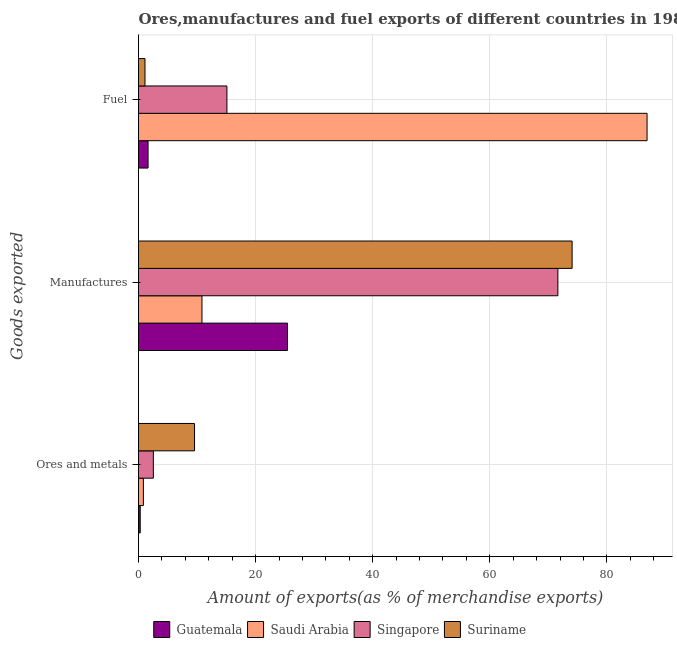How many groups of bars are there?
Your answer should be very brief. 3. What is the label of the 1st group of bars from the top?
Make the answer very short. Fuel. What is the percentage of ores and metals exports in Saudi Arabia?
Give a very brief answer. 0.83. Across all countries, what is the maximum percentage of ores and metals exports?
Give a very brief answer. 9.57. Across all countries, what is the minimum percentage of ores and metals exports?
Your response must be concise. 0.29. In which country was the percentage of ores and metals exports maximum?
Give a very brief answer. Suriname. In which country was the percentage of manufactures exports minimum?
Provide a short and direct response. Saudi Arabia. What is the total percentage of manufactures exports in the graph?
Keep it short and to the point. 181.98. What is the difference between the percentage of manufactures exports in Guatemala and that in Singapore?
Make the answer very short. -46.2. What is the difference between the percentage of ores and metals exports in Suriname and the percentage of fuel exports in Singapore?
Provide a short and direct response. -5.53. What is the average percentage of manufactures exports per country?
Keep it short and to the point. 45.49. What is the difference between the percentage of manufactures exports and percentage of fuel exports in Saudi Arabia?
Your response must be concise. -76.03. What is the ratio of the percentage of manufactures exports in Guatemala to that in Singapore?
Offer a terse response. 0.36. What is the difference between the highest and the second highest percentage of manufactures exports?
Offer a terse response. 2.43. What is the difference between the highest and the lowest percentage of fuel exports?
Your response must be concise. 85.76. In how many countries, is the percentage of fuel exports greater than the average percentage of fuel exports taken over all countries?
Make the answer very short. 1. What does the 1st bar from the top in Ores and metals represents?
Offer a very short reply. Suriname. What does the 3rd bar from the bottom in Fuel represents?
Ensure brevity in your answer.  Singapore. Is it the case that in every country, the sum of the percentage of ores and metals exports and percentage of manufactures exports is greater than the percentage of fuel exports?
Offer a very short reply. No. Are all the bars in the graph horizontal?
Ensure brevity in your answer.  Yes. How many countries are there in the graph?
Give a very brief answer. 4. Are the values on the major ticks of X-axis written in scientific E-notation?
Give a very brief answer. No. Does the graph contain grids?
Your response must be concise. Yes. Where does the legend appear in the graph?
Offer a very short reply. Bottom center. What is the title of the graph?
Make the answer very short. Ores,manufactures and fuel exports of different countries in 1989. What is the label or title of the X-axis?
Offer a very short reply. Amount of exports(as % of merchandise exports). What is the label or title of the Y-axis?
Offer a very short reply. Goods exported. What is the Amount of exports(as % of merchandise exports) of Guatemala in Ores and metals?
Make the answer very short. 0.29. What is the Amount of exports(as % of merchandise exports) of Saudi Arabia in Ores and metals?
Your response must be concise. 0.83. What is the Amount of exports(as % of merchandise exports) in Singapore in Ores and metals?
Offer a very short reply. 2.53. What is the Amount of exports(as % of merchandise exports) of Suriname in Ores and metals?
Provide a succinct answer. 9.57. What is the Amount of exports(as % of merchandise exports) of Guatemala in Manufactures?
Make the answer very short. 25.44. What is the Amount of exports(as % of merchandise exports) in Saudi Arabia in Manufactures?
Offer a very short reply. 10.84. What is the Amount of exports(as % of merchandise exports) in Singapore in Manufactures?
Ensure brevity in your answer.  71.64. What is the Amount of exports(as % of merchandise exports) of Suriname in Manufactures?
Provide a succinct answer. 74.07. What is the Amount of exports(as % of merchandise exports) in Guatemala in Fuel?
Ensure brevity in your answer.  1.63. What is the Amount of exports(as % of merchandise exports) in Saudi Arabia in Fuel?
Make the answer very short. 86.87. What is the Amount of exports(as % of merchandise exports) in Singapore in Fuel?
Keep it short and to the point. 15.1. What is the Amount of exports(as % of merchandise exports) of Suriname in Fuel?
Your answer should be very brief. 1.11. Across all Goods exported, what is the maximum Amount of exports(as % of merchandise exports) of Guatemala?
Your response must be concise. 25.44. Across all Goods exported, what is the maximum Amount of exports(as % of merchandise exports) in Saudi Arabia?
Offer a very short reply. 86.87. Across all Goods exported, what is the maximum Amount of exports(as % of merchandise exports) in Singapore?
Your response must be concise. 71.64. Across all Goods exported, what is the maximum Amount of exports(as % of merchandise exports) of Suriname?
Provide a succinct answer. 74.07. Across all Goods exported, what is the minimum Amount of exports(as % of merchandise exports) of Guatemala?
Offer a terse response. 0.29. Across all Goods exported, what is the minimum Amount of exports(as % of merchandise exports) of Saudi Arabia?
Offer a terse response. 0.83. Across all Goods exported, what is the minimum Amount of exports(as % of merchandise exports) in Singapore?
Offer a very short reply. 2.53. Across all Goods exported, what is the minimum Amount of exports(as % of merchandise exports) in Suriname?
Give a very brief answer. 1.11. What is the total Amount of exports(as % of merchandise exports) of Guatemala in the graph?
Keep it short and to the point. 27.36. What is the total Amount of exports(as % of merchandise exports) of Saudi Arabia in the graph?
Your answer should be very brief. 98.54. What is the total Amount of exports(as % of merchandise exports) of Singapore in the graph?
Provide a succinct answer. 89.27. What is the total Amount of exports(as % of merchandise exports) of Suriname in the graph?
Provide a succinct answer. 84.75. What is the difference between the Amount of exports(as % of merchandise exports) of Guatemala in Ores and metals and that in Manufactures?
Give a very brief answer. -25.15. What is the difference between the Amount of exports(as % of merchandise exports) of Saudi Arabia in Ores and metals and that in Manufactures?
Give a very brief answer. -10. What is the difference between the Amount of exports(as % of merchandise exports) of Singapore in Ores and metals and that in Manufactures?
Provide a short and direct response. -69.1. What is the difference between the Amount of exports(as % of merchandise exports) of Suriname in Ores and metals and that in Manufactures?
Provide a short and direct response. -64.49. What is the difference between the Amount of exports(as % of merchandise exports) of Guatemala in Ores and metals and that in Fuel?
Give a very brief answer. -1.34. What is the difference between the Amount of exports(as % of merchandise exports) of Saudi Arabia in Ores and metals and that in Fuel?
Offer a very short reply. -86.04. What is the difference between the Amount of exports(as % of merchandise exports) of Singapore in Ores and metals and that in Fuel?
Your response must be concise. -12.57. What is the difference between the Amount of exports(as % of merchandise exports) of Suriname in Ores and metals and that in Fuel?
Keep it short and to the point. 8.47. What is the difference between the Amount of exports(as % of merchandise exports) of Guatemala in Manufactures and that in Fuel?
Give a very brief answer. 23.81. What is the difference between the Amount of exports(as % of merchandise exports) in Saudi Arabia in Manufactures and that in Fuel?
Your answer should be very brief. -76.03. What is the difference between the Amount of exports(as % of merchandise exports) of Singapore in Manufactures and that in Fuel?
Provide a succinct answer. 56.53. What is the difference between the Amount of exports(as % of merchandise exports) in Suriname in Manufactures and that in Fuel?
Offer a very short reply. 72.96. What is the difference between the Amount of exports(as % of merchandise exports) of Guatemala in Ores and metals and the Amount of exports(as % of merchandise exports) of Saudi Arabia in Manufactures?
Your answer should be compact. -10.55. What is the difference between the Amount of exports(as % of merchandise exports) in Guatemala in Ores and metals and the Amount of exports(as % of merchandise exports) in Singapore in Manufactures?
Your answer should be very brief. -71.34. What is the difference between the Amount of exports(as % of merchandise exports) of Guatemala in Ores and metals and the Amount of exports(as % of merchandise exports) of Suriname in Manufactures?
Keep it short and to the point. -73.77. What is the difference between the Amount of exports(as % of merchandise exports) of Saudi Arabia in Ores and metals and the Amount of exports(as % of merchandise exports) of Singapore in Manufactures?
Give a very brief answer. -70.8. What is the difference between the Amount of exports(as % of merchandise exports) in Saudi Arabia in Ores and metals and the Amount of exports(as % of merchandise exports) in Suriname in Manufactures?
Provide a short and direct response. -73.23. What is the difference between the Amount of exports(as % of merchandise exports) in Singapore in Ores and metals and the Amount of exports(as % of merchandise exports) in Suriname in Manufactures?
Provide a short and direct response. -71.53. What is the difference between the Amount of exports(as % of merchandise exports) of Guatemala in Ores and metals and the Amount of exports(as % of merchandise exports) of Saudi Arabia in Fuel?
Make the answer very short. -86.58. What is the difference between the Amount of exports(as % of merchandise exports) in Guatemala in Ores and metals and the Amount of exports(as % of merchandise exports) in Singapore in Fuel?
Offer a terse response. -14.81. What is the difference between the Amount of exports(as % of merchandise exports) in Guatemala in Ores and metals and the Amount of exports(as % of merchandise exports) in Suriname in Fuel?
Your answer should be very brief. -0.81. What is the difference between the Amount of exports(as % of merchandise exports) of Saudi Arabia in Ores and metals and the Amount of exports(as % of merchandise exports) of Singapore in Fuel?
Your answer should be compact. -14.27. What is the difference between the Amount of exports(as % of merchandise exports) of Saudi Arabia in Ores and metals and the Amount of exports(as % of merchandise exports) of Suriname in Fuel?
Offer a very short reply. -0.27. What is the difference between the Amount of exports(as % of merchandise exports) in Singapore in Ores and metals and the Amount of exports(as % of merchandise exports) in Suriname in Fuel?
Your response must be concise. 1.43. What is the difference between the Amount of exports(as % of merchandise exports) of Guatemala in Manufactures and the Amount of exports(as % of merchandise exports) of Saudi Arabia in Fuel?
Offer a very short reply. -61.43. What is the difference between the Amount of exports(as % of merchandise exports) of Guatemala in Manufactures and the Amount of exports(as % of merchandise exports) of Singapore in Fuel?
Your answer should be compact. 10.34. What is the difference between the Amount of exports(as % of merchandise exports) in Guatemala in Manufactures and the Amount of exports(as % of merchandise exports) in Suriname in Fuel?
Ensure brevity in your answer.  24.33. What is the difference between the Amount of exports(as % of merchandise exports) of Saudi Arabia in Manufactures and the Amount of exports(as % of merchandise exports) of Singapore in Fuel?
Offer a very short reply. -4.27. What is the difference between the Amount of exports(as % of merchandise exports) in Saudi Arabia in Manufactures and the Amount of exports(as % of merchandise exports) in Suriname in Fuel?
Offer a very short reply. 9.73. What is the difference between the Amount of exports(as % of merchandise exports) in Singapore in Manufactures and the Amount of exports(as % of merchandise exports) in Suriname in Fuel?
Offer a terse response. 70.53. What is the average Amount of exports(as % of merchandise exports) in Guatemala per Goods exported?
Your answer should be very brief. 9.12. What is the average Amount of exports(as % of merchandise exports) in Saudi Arabia per Goods exported?
Ensure brevity in your answer.  32.85. What is the average Amount of exports(as % of merchandise exports) of Singapore per Goods exported?
Provide a succinct answer. 29.76. What is the average Amount of exports(as % of merchandise exports) in Suriname per Goods exported?
Your answer should be very brief. 28.25. What is the difference between the Amount of exports(as % of merchandise exports) of Guatemala and Amount of exports(as % of merchandise exports) of Saudi Arabia in Ores and metals?
Keep it short and to the point. -0.54. What is the difference between the Amount of exports(as % of merchandise exports) in Guatemala and Amount of exports(as % of merchandise exports) in Singapore in Ores and metals?
Give a very brief answer. -2.24. What is the difference between the Amount of exports(as % of merchandise exports) of Guatemala and Amount of exports(as % of merchandise exports) of Suriname in Ores and metals?
Provide a succinct answer. -9.28. What is the difference between the Amount of exports(as % of merchandise exports) in Saudi Arabia and Amount of exports(as % of merchandise exports) in Singapore in Ores and metals?
Make the answer very short. -1.7. What is the difference between the Amount of exports(as % of merchandise exports) of Saudi Arabia and Amount of exports(as % of merchandise exports) of Suriname in Ores and metals?
Make the answer very short. -8.74. What is the difference between the Amount of exports(as % of merchandise exports) of Singapore and Amount of exports(as % of merchandise exports) of Suriname in Ores and metals?
Keep it short and to the point. -7.04. What is the difference between the Amount of exports(as % of merchandise exports) in Guatemala and Amount of exports(as % of merchandise exports) in Saudi Arabia in Manufactures?
Provide a short and direct response. 14.6. What is the difference between the Amount of exports(as % of merchandise exports) of Guatemala and Amount of exports(as % of merchandise exports) of Singapore in Manufactures?
Your answer should be very brief. -46.2. What is the difference between the Amount of exports(as % of merchandise exports) of Guatemala and Amount of exports(as % of merchandise exports) of Suriname in Manufactures?
Offer a terse response. -48.63. What is the difference between the Amount of exports(as % of merchandise exports) in Saudi Arabia and Amount of exports(as % of merchandise exports) in Singapore in Manufactures?
Provide a succinct answer. -60.8. What is the difference between the Amount of exports(as % of merchandise exports) of Saudi Arabia and Amount of exports(as % of merchandise exports) of Suriname in Manufactures?
Keep it short and to the point. -63.23. What is the difference between the Amount of exports(as % of merchandise exports) of Singapore and Amount of exports(as % of merchandise exports) of Suriname in Manufactures?
Give a very brief answer. -2.43. What is the difference between the Amount of exports(as % of merchandise exports) of Guatemala and Amount of exports(as % of merchandise exports) of Saudi Arabia in Fuel?
Give a very brief answer. -85.24. What is the difference between the Amount of exports(as % of merchandise exports) of Guatemala and Amount of exports(as % of merchandise exports) of Singapore in Fuel?
Offer a terse response. -13.47. What is the difference between the Amount of exports(as % of merchandise exports) of Guatemala and Amount of exports(as % of merchandise exports) of Suriname in Fuel?
Keep it short and to the point. 0.52. What is the difference between the Amount of exports(as % of merchandise exports) in Saudi Arabia and Amount of exports(as % of merchandise exports) in Singapore in Fuel?
Provide a short and direct response. 71.77. What is the difference between the Amount of exports(as % of merchandise exports) of Saudi Arabia and Amount of exports(as % of merchandise exports) of Suriname in Fuel?
Provide a short and direct response. 85.76. What is the difference between the Amount of exports(as % of merchandise exports) of Singapore and Amount of exports(as % of merchandise exports) of Suriname in Fuel?
Ensure brevity in your answer.  14. What is the ratio of the Amount of exports(as % of merchandise exports) of Guatemala in Ores and metals to that in Manufactures?
Provide a succinct answer. 0.01. What is the ratio of the Amount of exports(as % of merchandise exports) of Saudi Arabia in Ores and metals to that in Manufactures?
Your response must be concise. 0.08. What is the ratio of the Amount of exports(as % of merchandise exports) in Singapore in Ores and metals to that in Manufactures?
Provide a succinct answer. 0.04. What is the ratio of the Amount of exports(as % of merchandise exports) in Suriname in Ores and metals to that in Manufactures?
Provide a succinct answer. 0.13. What is the ratio of the Amount of exports(as % of merchandise exports) in Guatemala in Ores and metals to that in Fuel?
Provide a short and direct response. 0.18. What is the ratio of the Amount of exports(as % of merchandise exports) in Saudi Arabia in Ores and metals to that in Fuel?
Provide a succinct answer. 0.01. What is the ratio of the Amount of exports(as % of merchandise exports) in Singapore in Ores and metals to that in Fuel?
Your response must be concise. 0.17. What is the ratio of the Amount of exports(as % of merchandise exports) of Suriname in Ores and metals to that in Fuel?
Provide a short and direct response. 8.65. What is the ratio of the Amount of exports(as % of merchandise exports) in Guatemala in Manufactures to that in Fuel?
Ensure brevity in your answer.  15.59. What is the ratio of the Amount of exports(as % of merchandise exports) in Saudi Arabia in Manufactures to that in Fuel?
Provide a succinct answer. 0.12. What is the ratio of the Amount of exports(as % of merchandise exports) in Singapore in Manufactures to that in Fuel?
Ensure brevity in your answer.  4.74. What is the ratio of the Amount of exports(as % of merchandise exports) in Suriname in Manufactures to that in Fuel?
Give a very brief answer. 66.89. What is the difference between the highest and the second highest Amount of exports(as % of merchandise exports) in Guatemala?
Provide a short and direct response. 23.81. What is the difference between the highest and the second highest Amount of exports(as % of merchandise exports) of Saudi Arabia?
Provide a short and direct response. 76.03. What is the difference between the highest and the second highest Amount of exports(as % of merchandise exports) of Singapore?
Give a very brief answer. 56.53. What is the difference between the highest and the second highest Amount of exports(as % of merchandise exports) of Suriname?
Provide a succinct answer. 64.49. What is the difference between the highest and the lowest Amount of exports(as % of merchandise exports) in Guatemala?
Your answer should be compact. 25.15. What is the difference between the highest and the lowest Amount of exports(as % of merchandise exports) in Saudi Arabia?
Make the answer very short. 86.04. What is the difference between the highest and the lowest Amount of exports(as % of merchandise exports) in Singapore?
Your response must be concise. 69.1. What is the difference between the highest and the lowest Amount of exports(as % of merchandise exports) in Suriname?
Keep it short and to the point. 72.96. 